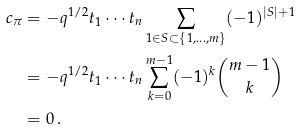<formula> <loc_0><loc_0><loc_500><loc_500>c _ { \pi } & = - q ^ { 1 / 2 } t _ { 1 } \cdots t _ { n } \sum _ { 1 \in S \subset \{ 1 , \dots , m \} } ( - 1 ) ^ { | S | + 1 } \\ & = - q ^ { 1 / 2 } t _ { 1 } \cdots t _ { n } \sum _ { k = 0 } ^ { m - 1 } ( - 1 ) ^ { k } \binom { m - 1 } k \\ & = 0 \, .</formula> 